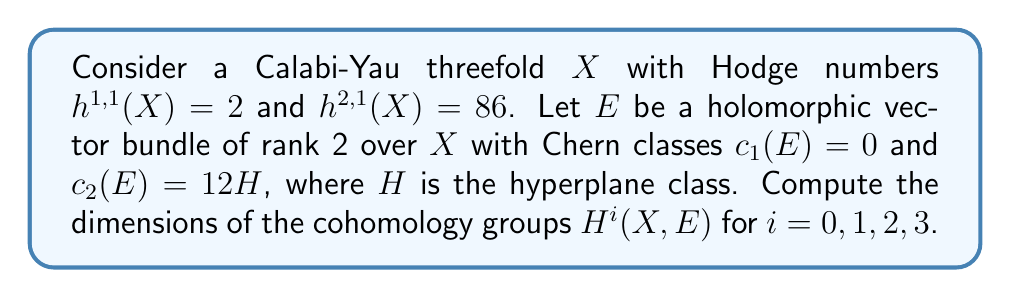Teach me how to tackle this problem. To solve this problem, we'll use the following steps:

1) First, recall that for a Calabi-Yau threefold $X$, we have $\chi(X) = 2(h^{1,1} - h^{2,1})$.

2) In this case, $\chi(X) = 2(2 - 86) = -168$.

3) For a vector bundle $E$ on a smooth projective variety $X$, the Hirzebruch-Riemann-Roch theorem states:

   $$\chi(E) = \int_X \text{ch}(E) \cdot \text{td}(X)$$

   where $\text{ch}(E)$ is the Chern character of $E$ and $\text{td}(X)$ is the Todd class of $X$.

4) For a rank 2 bundle with $c_1(E) = 0$, we have:

   $$\text{ch}(E) = 2 - c_2(E) + \frac{1}{12}c_2(E)c_1(X) - \frac{1}{24}c_3(E)$$

5) For a Calabi-Yau threefold, $c_1(X) = 0$ and $\text{td}(X) = 1 + \frac{1}{12}c_2(X) + \frac{\chi(X)}{24}\text{pt}$.

6) Multiplying these out and integrating, we get:

   $$\chi(E) = \int_X (2 - 12H) \cdot (1 + \frac{1}{12}c_2(X) + \frac{-168}{24}\text{pt})$$

   $$= -168 + \frac{1}{6}\int_X c_2(X) - \int_X 12H \cdot \frac{1}{12}c_2(X)$$

7) For a Calabi-Yau threefold, $\int_X c_2(X) \cdot H = 24$. Therefore:

   $$\chi(E) = -168 + \frac{1}{6} \cdot 24 - 12 \cdot 2 = -168 + 4 - 24 = -188$$

8) By Serre duality on a Calabi-Yau threefold, we have $h^i(X, E) = h^{3-i}(X, E)$ for $i = 0, 1, 2, 3$.

9) Also, for a stable bundle on a Calabi-Yau threefold, $H^0(X, E) = H^3(X, E) = 0$.

10) Therefore, $h^1(X, E) = h^2(X, E)$, and we can write:

    $$\chi(E) = -h^1(X, E) + h^2(X, E) = -188$$

11) This implies $h^1(X, E) = h^2(X, E) = 94$.

Therefore, $h^0(X, E) = 0$, $h^1(X, E) = 94$, $h^2(X, E) = 94$, and $h^3(X, E) = 0$.
Answer: $h^0(X, E) = 0$, $h^1(X, E) = 94$, $h^2(X, E) = 94$, $h^3(X, E) = 0$ 